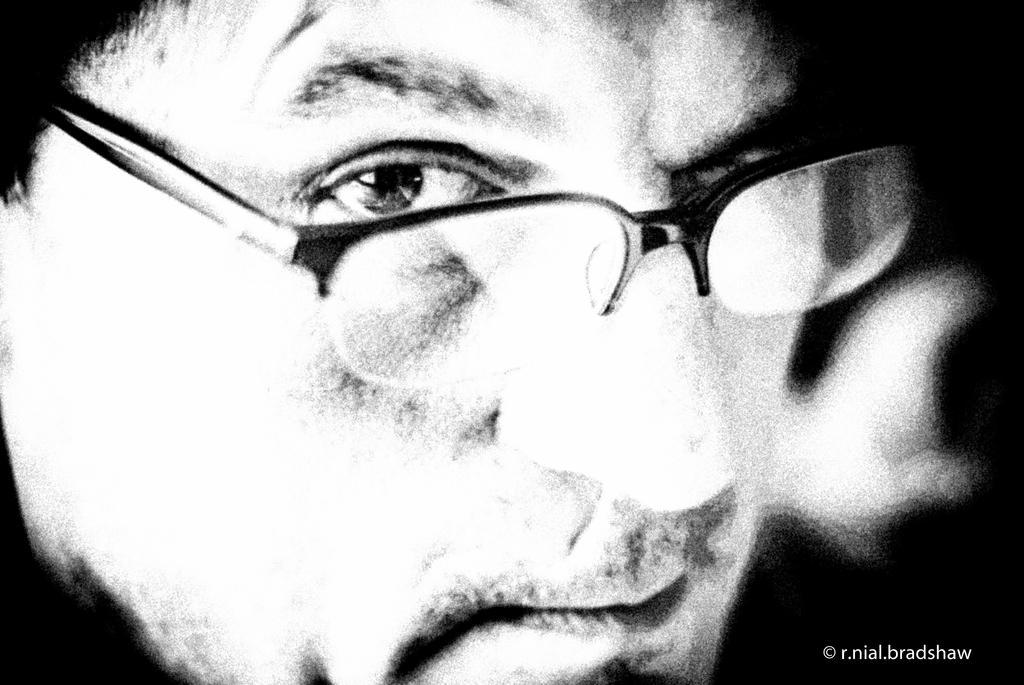Can you describe this image briefly? It is an edited image. In this image I can see a person's face. He is wearing spectacles. At the bottom right side of the image there is a watermark.   